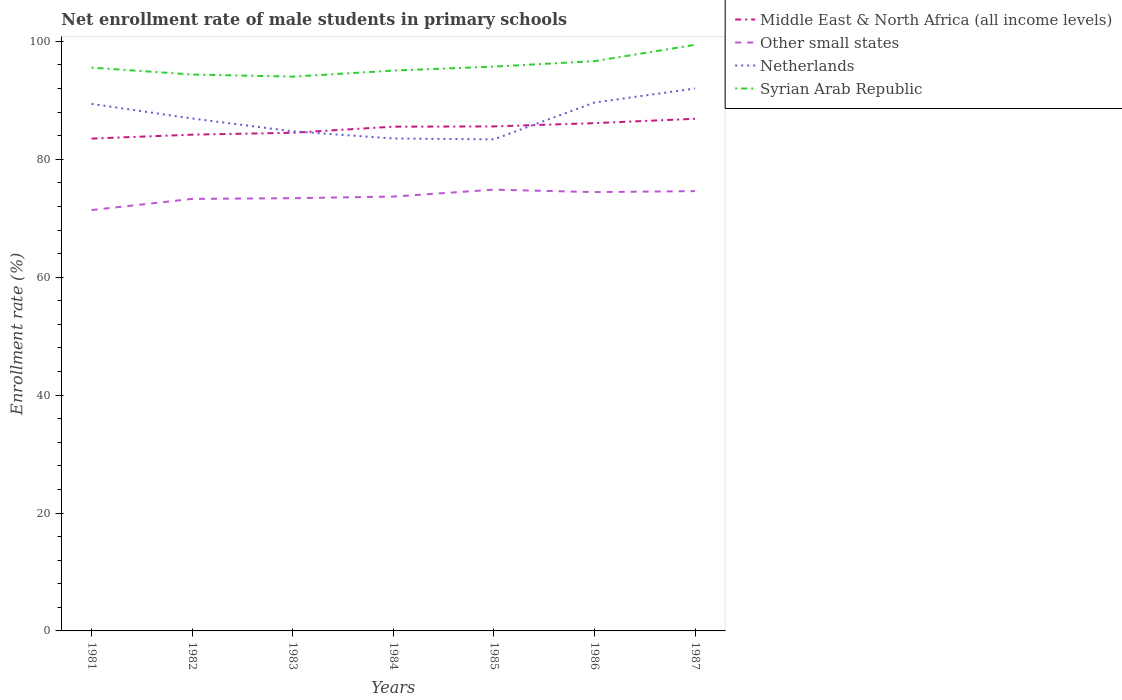Across all years, what is the maximum net enrollment rate of male students in primary schools in Syrian Arab Republic?
Your answer should be very brief. 94.01. In which year was the net enrollment rate of male students in primary schools in Other small states maximum?
Provide a short and direct response. 1981. What is the total net enrollment rate of male students in primary schools in Netherlands in the graph?
Keep it short and to the point. -5.09. What is the difference between the highest and the second highest net enrollment rate of male students in primary schools in Middle East & North Africa (all income levels)?
Provide a short and direct response. 3.36. Are the values on the major ticks of Y-axis written in scientific E-notation?
Provide a short and direct response. No. Does the graph contain grids?
Your answer should be compact. No. Where does the legend appear in the graph?
Keep it short and to the point. Top right. How many legend labels are there?
Ensure brevity in your answer.  4. How are the legend labels stacked?
Make the answer very short. Vertical. What is the title of the graph?
Offer a terse response. Net enrollment rate of male students in primary schools. Does "Ireland" appear as one of the legend labels in the graph?
Offer a very short reply. No. What is the label or title of the X-axis?
Provide a succinct answer. Years. What is the label or title of the Y-axis?
Provide a succinct answer. Enrollment rate (%). What is the Enrollment rate (%) in Middle East & North Africa (all income levels) in 1981?
Give a very brief answer. 83.5. What is the Enrollment rate (%) of Other small states in 1981?
Provide a succinct answer. 71.39. What is the Enrollment rate (%) of Netherlands in 1981?
Offer a very short reply. 89.39. What is the Enrollment rate (%) of Syrian Arab Republic in 1981?
Your answer should be very brief. 95.54. What is the Enrollment rate (%) of Middle East & North Africa (all income levels) in 1982?
Keep it short and to the point. 84.17. What is the Enrollment rate (%) in Other small states in 1982?
Give a very brief answer. 73.27. What is the Enrollment rate (%) of Netherlands in 1982?
Offer a terse response. 86.91. What is the Enrollment rate (%) in Syrian Arab Republic in 1982?
Ensure brevity in your answer.  94.37. What is the Enrollment rate (%) of Middle East & North Africa (all income levels) in 1983?
Offer a terse response. 84.49. What is the Enrollment rate (%) of Other small states in 1983?
Give a very brief answer. 73.4. What is the Enrollment rate (%) of Netherlands in 1983?
Offer a terse response. 84.73. What is the Enrollment rate (%) in Syrian Arab Republic in 1983?
Your response must be concise. 94.01. What is the Enrollment rate (%) of Middle East & North Africa (all income levels) in 1984?
Offer a terse response. 85.53. What is the Enrollment rate (%) of Other small states in 1984?
Ensure brevity in your answer.  73.67. What is the Enrollment rate (%) in Netherlands in 1984?
Give a very brief answer. 83.52. What is the Enrollment rate (%) of Syrian Arab Republic in 1984?
Your answer should be compact. 95.04. What is the Enrollment rate (%) of Middle East & North Africa (all income levels) in 1985?
Provide a short and direct response. 85.57. What is the Enrollment rate (%) in Other small states in 1985?
Make the answer very short. 74.84. What is the Enrollment rate (%) in Netherlands in 1985?
Your answer should be very brief. 83.37. What is the Enrollment rate (%) in Syrian Arab Republic in 1985?
Your answer should be compact. 95.71. What is the Enrollment rate (%) in Middle East & North Africa (all income levels) in 1986?
Make the answer very short. 86.13. What is the Enrollment rate (%) of Other small states in 1986?
Keep it short and to the point. 74.43. What is the Enrollment rate (%) in Netherlands in 1986?
Your answer should be compact. 89.61. What is the Enrollment rate (%) in Syrian Arab Republic in 1986?
Your response must be concise. 96.65. What is the Enrollment rate (%) of Middle East & North Africa (all income levels) in 1987?
Your response must be concise. 86.87. What is the Enrollment rate (%) of Other small states in 1987?
Offer a very short reply. 74.6. What is the Enrollment rate (%) in Netherlands in 1987?
Provide a short and direct response. 92. What is the Enrollment rate (%) of Syrian Arab Republic in 1987?
Give a very brief answer. 99.41. Across all years, what is the maximum Enrollment rate (%) in Middle East & North Africa (all income levels)?
Ensure brevity in your answer.  86.87. Across all years, what is the maximum Enrollment rate (%) of Other small states?
Offer a very short reply. 74.84. Across all years, what is the maximum Enrollment rate (%) in Netherlands?
Provide a succinct answer. 92. Across all years, what is the maximum Enrollment rate (%) of Syrian Arab Republic?
Provide a succinct answer. 99.41. Across all years, what is the minimum Enrollment rate (%) of Middle East & North Africa (all income levels)?
Ensure brevity in your answer.  83.5. Across all years, what is the minimum Enrollment rate (%) in Other small states?
Keep it short and to the point. 71.39. Across all years, what is the minimum Enrollment rate (%) in Netherlands?
Keep it short and to the point. 83.37. Across all years, what is the minimum Enrollment rate (%) in Syrian Arab Republic?
Ensure brevity in your answer.  94.01. What is the total Enrollment rate (%) of Middle East & North Africa (all income levels) in the graph?
Give a very brief answer. 596.25. What is the total Enrollment rate (%) in Other small states in the graph?
Ensure brevity in your answer.  515.6. What is the total Enrollment rate (%) in Netherlands in the graph?
Provide a short and direct response. 609.54. What is the total Enrollment rate (%) of Syrian Arab Republic in the graph?
Your response must be concise. 670.73. What is the difference between the Enrollment rate (%) in Middle East & North Africa (all income levels) in 1981 and that in 1982?
Provide a short and direct response. -0.67. What is the difference between the Enrollment rate (%) in Other small states in 1981 and that in 1982?
Offer a terse response. -1.89. What is the difference between the Enrollment rate (%) in Netherlands in 1981 and that in 1982?
Ensure brevity in your answer.  2.47. What is the difference between the Enrollment rate (%) of Syrian Arab Republic in 1981 and that in 1982?
Make the answer very short. 1.17. What is the difference between the Enrollment rate (%) in Middle East & North Africa (all income levels) in 1981 and that in 1983?
Give a very brief answer. -0.99. What is the difference between the Enrollment rate (%) in Other small states in 1981 and that in 1983?
Provide a succinct answer. -2.01. What is the difference between the Enrollment rate (%) in Netherlands in 1981 and that in 1983?
Make the answer very short. 4.65. What is the difference between the Enrollment rate (%) in Syrian Arab Republic in 1981 and that in 1983?
Give a very brief answer. 1.52. What is the difference between the Enrollment rate (%) in Middle East & North Africa (all income levels) in 1981 and that in 1984?
Your response must be concise. -2.02. What is the difference between the Enrollment rate (%) of Other small states in 1981 and that in 1984?
Keep it short and to the point. -2.29. What is the difference between the Enrollment rate (%) of Netherlands in 1981 and that in 1984?
Your response must be concise. 5.87. What is the difference between the Enrollment rate (%) in Syrian Arab Republic in 1981 and that in 1984?
Make the answer very short. 0.5. What is the difference between the Enrollment rate (%) of Middle East & North Africa (all income levels) in 1981 and that in 1985?
Your response must be concise. -2.06. What is the difference between the Enrollment rate (%) of Other small states in 1981 and that in 1985?
Offer a very short reply. -3.46. What is the difference between the Enrollment rate (%) in Netherlands in 1981 and that in 1985?
Provide a short and direct response. 6.01. What is the difference between the Enrollment rate (%) in Syrian Arab Republic in 1981 and that in 1985?
Make the answer very short. -0.18. What is the difference between the Enrollment rate (%) of Middle East & North Africa (all income levels) in 1981 and that in 1986?
Offer a terse response. -2.62. What is the difference between the Enrollment rate (%) of Other small states in 1981 and that in 1986?
Provide a short and direct response. -3.05. What is the difference between the Enrollment rate (%) in Netherlands in 1981 and that in 1986?
Give a very brief answer. -0.23. What is the difference between the Enrollment rate (%) of Syrian Arab Republic in 1981 and that in 1986?
Ensure brevity in your answer.  -1.11. What is the difference between the Enrollment rate (%) in Middle East & North Africa (all income levels) in 1981 and that in 1987?
Ensure brevity in your answer.  -3.36. What is the difference between the Enrollment rate (%) of Other small states in 1981 and that in 1987?
Give a very brief answer. -3.21. What is the difference between the Enrollment rate (%) of Netherlands in 1981 and that in 1987?
Make the answer very short. -2.62. What is the difference between the Enrollment rate (%) in Syrian Arab Republic in 1981 and that in 1987?
Your answer should be very brief. -3.87. What is the difference between the Enrollment rate (%) of Middle East & North Africa (all income levels) in 1982 and that in 1983?
Your response must be concise. -0.32. What is the difference between the Enrollment rate (%) in Other small states in 1982 and that in 1983?
Offer a terse response. -0.12. What is the difference between the Enrollment rate (%) of Netherlands in 1982 and that in 1983?
Your response must be concise. 2.18. What is the difference between the Enrollment rate (%) of Syrian Arab Republic in 1982 and that in 1983?
Offer a terse response. 0.36. What is the difference between the Enrollment rate (%) of Middle East & North Africa (all income levels) in 1982 and that in 1984?
Make the answer very short. -1.35. What is the difference between the Enrollment rate (%) of Other small states in 1982 and that in 1984?
Offer a very short reply. -0.4. What is the difference between the Enrollment rate (%) in Netherlands in 1982 and that in 1984?
Provide a short and direct response. 3.39. What is the difference between the Enrollment rate (%) in Syrian Arab Republic in 1982 and that in 1984?
Your answer should be compact. -0.67. What is the difference between the Enrollment rate (%) of Middle East & North Africa (all income levels) in 1982 and that in 1985?
Your response must be concise. -1.4. What is the difference between the Enrollment rate (%) in Other small states in 1982 and that in 1985?
Your answer should be very brief. -1.57. What is the difference between the Enrollment rate (%) of Netherlands in 1982 and that in 1985?
Offer a terse response. 3.54. What is the difference between the Enrollment rate (%) of Syrian Arab Republic in 1982 and that in 1985?
Your answer should be very brief. -1.34. What is the difference between the Enrollment rate (%) of Middle East & North Africa (all income levels) in 1982 and that in 1986?
Keep it short and to the point. -1.95. What is the difference between the Enrollment rate (%) in Other small states in 1982 and that in 1986?
Your answer should be compact. -1.16. What is the difference between the Enrollment rate (%) of Netherlands in 1982 and that in 1986?
Your response must be concise. -2.7. What is the difference between the Enrollment rate (%) of Syrian Arab Republic in 1982 and that in 1986?
Your response must be concise. -2.27. What is the difference between the Enrollment rate (%) of Middle East & North Africa (all income levels) in 1982 and that in 1987?
Your answer should be very brief. -2.69. What is the difference between the Enrollment rate (%) in Other small states in 1982 and that in 1987?
Make the answer very short. -1.32. What is the difference between the Enrollment rate (%) of Netherlands in 1982 and that in 1987?
Give a very brief answer. -5.09. What is the difference between the Enrollment rate (%) in Syrian Arab Republic in 1982 and that in 1987?
Provide a short and direct response. -5.03. What is the difference between the Enrollment rate (%) of Middle East & North Africa (all income levels) in 1983 and that in 1984?
Give a very brief answer. -1.03. What is the difference between the Enrollment rate (%) in Other small states in 1983 and that in 1984?
Offer a terse response. -0.28. What is the difference between the Enrollment rate (%) of Netherlands in 1983 and that in 1984?
Make the answer very short. 1.22. What is the difference between the Enrollment rate (%) of Syrian Arab Republic in 1983 and that in 1984?
Give a very brief answer. -1.03. What is the difference between the Enrollment rate (%) in Middle East & North Africa (all income levels) in 1983 and that in 1985?
Offer a terse response. -1.08. What is the difference between the Enrollment rate (%) in Other small states in 1983 and that in 1985?
Provide a succinct answer. -1.45. What is the difference between the Enrollment rate (%) of Netherlands in 1983 and that in 1985?
Ensure brevity in your answer.  1.36. What is the difference between the Enrollment rate (%) in Syrian Arab Republic in 1983 and that in 1985?
Your answer should be compact. -1.7. What is the difference between the Enrollment rate (%) of Middle East & North Africa (all income levels) in 1983 and that in 1986?
Offer a very short reply. -1.63. What is the difference between the Enrollment rate (%) of Other small states in 1983 and that in 1986?
Give a very brief answer. -1.03. What is the difference between the Enrollment rate (%) in Netherlands in 1983 and that in 1986?
Provide a succinct answer. -4.88. What is the difference between the Enrollment rate (%) of Syrian Arab Republic in 1983 and that in 1986?
Your answer should be compact. -2.63. What is the difference between the Enrollment rate (%) in Middle East & North Africa (all income levels) in 1983 and that in 1987?
Keep it short and to the point. -2.37. What is the difference between the Enrollment rate (%) of Other small states in 1983 and that in 1987?
Your response must be concise. -1.2. What is the difference between the Enrollment rate (%) in Netherlands in 1983 and that in 1987?
Your answer should be compact. -7.27. What is the difference between the Enrollment rate (%) of Syrian Arab Republic in 1983 and that in 1987?
Ensure brevity in your answer.  -5.39. What is the difference between the Enrollment rate (%) in Middle East & North Africa (all income levels) in 1984 and that in 1985?
Provide a succinct answer. -0.04. What is the difference between the Enrollment rate (%) of Other small states in 1984 and that in 1985?
Keep it short and to the point. -1.17. What is the difference between the Enrollment rate (%) of Netherlands in 1984 and that in 1985?
Provide a short and direct response. 0.15. What is the difference between the Enrollment rate (%) of Syrian Arab Republic in 1984 and that in 1985?
Your answer should be very brief. -0.68. What is the difference between the Enrollment rate (%) in Middle East & North Africa (all income levels) in 1984 and that in 1986?
Provide a succinct answer. -0.6. What is the difference between the Enrollment rate (%) in Other small states in 1984 and that in 1986?
Ensure brevity in your answer.  -0.76. What is the difference between the Enrollment rate (%) in Netherlands in 1984 and that in 1986?
Offer a terse response. -6.09. What is the difference between the Enrollment rate (%) in Syrian Arab Republic in 1984 and that in 1986?
Your answer should be very brief. -1.61. What is the difference between the Enrollment rate (%) in Middle East & North Africa (all income levels) in 1984 and that in 1987?
Make the answer very short. -1.34. What is the difference between the Enrollment rate (%) of Other small states in 1984 and that in 1987?
Provide a short and direct response. -0.93. What is the difference between the Enrollment rate (%) in Netherlands in 1984 and that in 1987?
Your response must be concise. -8.49. What is the difference between the Enrollment rate (%) in Syrian Arab Republic in 1984 and that in 1987?
Your answer should be very brief. -4.37. What is the difference between the Enrollment rate (%) in Middle East & North Africa (all income levels) in 1985 and that in 1986?
Provide a succinct answer. -0.56. What is the difference between the Enrollment rate (%) of Other small states in 1985 and that in 1986?
Provide a short and direct response. 0.41. What is the difference between the Enrollment rate (%) of Netherlands in 1985 and that in 1986?
Ensure brevity in your answer.  -6.24. What is the difference between the Enrollment rate (%) of Syrian Arab Republic in 1985 and that in 1986?
Your response must be concise. -0.93. What is the difference between the Enrollment rate (%) of Middle East & North Africa (all income levels) in 1985 and that in 1987?
Offer a very short reply. -1.3. What is the difference between the Enrollment rate (%) in Other small states in 1985 and that in 1987?
Your answer should be compact. 0.25. What is the difference between the Enrollment rate (%) of Netherlands in 1985 and that in 1987?
Offer a very short reply. -8.63. What is the difference between the Enrollment rate (%) in Syrian Arab Republic in 1985 and that in 1987?
Offer a very short reply. -3.69. What is the difference between the Enrollment rate (%) in Middle East & North Africa (all income levels) in 1986 and that in 1987?
Your response must be concise. -0.74. What is the difference between the Enrollment rate (%) in Other small states in 1986 and that in 1987?
Give a very brief answer. -0.17. What is the difference between the Enrollment rate (%) in Netherlands in 1986 and that in 1987?
Ensure brevity in your answer.  -2.39. What is the difference between the Enrollment rate (%) of Syrian Arab Republic in 1986 and that in 1987?
Your response must be concise. -2.76. What is the difference between the Enrollment rate (%) of Middle East & North Africa (all income levels) in 1981 and the Enrollment rate (%) of Other small states in 1982?
Offer a terse response. 10.23. What is the difference between the Enrollment rate (%) of Middle East & North Africa (all income levels) in 1981 and the Enrollment rate (%) of Netherlands in 1982?
Your answer should be very brief. -3.41. What is the difference between the Enrollment rate (%) of Middle East & North Africa (all income levels) in 1981 and the Enrollment rate (%) of Syrian Arab Republic in 1982?
Keep it short and to the point. -10.87. What is the difference between the Enrollment rate (%) of Other small states in 1981 and the Enrollment rate (%) of Netherlands in 1982?
Offer a terse response. -15.53. What is the difference between the Enrollment rate (%) in Other small states in 1981 and the Enrollment rate (%) in Syrian Arab Republic in 1982?
Offer a terse response. -22.99. What is the difference between the Enrollment rate (%) of Netherlands in 1981 and the Enrollment rate (%) of Syrian Arab Republic in 1982?
Your answer should be compact. -4.98. What is the difference between the Enrollment rate (%) of Middle East & North Africa (all income levels) in 1981 and the Enrollment rate (%) of Other small states in 1983?
Your response must be concise. 10.11. What is the difference between the Enrollment rate (%) in Middle East & North Africa (all income levels) in 1981 and the Enrollment rate (%) in Netherlands in 1983?
Offer a very short reply. -1.23. What is the difference between the Enrollment rate (%) of Middle East & North Africa (all income levels) in 1981 and the Enrollment rate (%) of Syrian Arab Republic in 1983?
Make the answer very short. -10.51. What is the difference between the Enrollment rate (%) in Other small states in 1981 and the Enrollment rate (%) in Netherlands in 1983?
Provide a short and direct response. -13.35. What is the difference between the Enrollment rate (%) in Other small states in 1981 and the Enrollment rate (%) in Syrian Arab Republic in 1983?
Offer a terse response. -22.63. What is the difference between the Enrollment rate (%) of Netherlands in 1981 and the Enrollment rate (%) of Syrian Arab Republic in 1983?
Make the answer very short. -4.63. What is the difference between the Enrollment rate (%) of Middle East & North Africa (all income levels) in 1981 and the Enrollment rate (%) of Other small states in 1984?
Make the answer very short. 9.83. What is the difference between the Enrollment rate (%) of Middle East & North Africa (all income levels) in 1981 and the Enrollment rate (%) of Netherlands in 1984?
Offer a very short reply. -0.02. What is the difference between the Enrollment rate (%) in Middle East & North Africa (all income levels) in 1981 and the Enrollment rate (%) in Syrian Arab Republic in 1984?
Make the answer very short. -11.54. What is the difference between the Enrollment rate (%) of Other small states in 1981 and the Enrollment rate (%) of Netherlands in 1984?
Provide a succinct answer. -12.13. What is the difference between the Enrollment rate (%) in Other small states in 1981 and the Enrollment rate (%) in Syrian Arab Republic in 1984?
Offer a terse response. -23.65. What is the difference between the Enrollment rate (%) of Netherlands in 1981 and the Enrollment rate (%) of Syrian Arab Republic in 1984?
Offer a very short reply. -5.65. What is the difference between the Enrollment rate (%) of Middle East & North Africa (all income levels) in 1981 and the Enrollment rate (%) of Other small states in 1985?
Offer a very short reply. 8.66. What is the difference between the Enrollment rate (%) of Middle East & North Africa (all income levels) in 1981 and the Enrollment rate (%) of Netherlands in 1985?
Keep it short and to the point. 0.13. What is the difference between the Enrollment rate (%) of Middle East & North Africa (all income levels) in 1981 and the Enrollment rate (%) of Syrian Arab Republic in 1985?
Your answer should be very brief. -12.21. What is the difference between the Enrollment rate (%) in Other small states in 1981 and the Enrollment rate (%) in Netherlands in 1985?
Make the answer very short. -11.99. What is the difference between the Enrollment rate (%) in Other small states in 1981 and the Enrollment rate (%) in Syrian Arab Republic in 1985?
Make the answer very short. -24.33. What is the difference between the Enrollment rate (%) in Netherlands in 1981 and the Enrollment rate (%) in Syrian Arab Republic in 1985?
Your response must be concise. -6.33. What is the difference between the Enrollment rate (%) in Middle East & North Africa (all income levels) in 1981 and the Enrollment rate (%) in Other small states in 1986?
Offer a very short reply. 9.07. What is the difference between the Enrollment rate (%) in Middle East & North Africa (all income levels) in 1981 and the Enrollment rate (%) in Netherlands in 1986?
Give a very brief answer. -6.11. What is the difference between the Enrollment rate (%) of Middle East & North Africa (all income levels) in 1981 and the Enrollment rate (%) of Syrian Arab Republic in 1986?
Ensure brevity in your answer.  -13.14. What is the difference between the Enrollment rate (%) in Other small states in 1981 and the Enrollment rate (%) in Netherlands in 1986?
Your answer should be very brief. -18.23. What is the difference between the Enrollment rate (%) in Other small states in 1981 and the Enrollment rate (%) in Syrian Arab Republic in 1986?
Give a very brief answer. -25.26. What is the difference between the Enrollment rate (%) of Netherlands in 1981 and the Enrollment rate (%) of Syrian Arab Republic in 1986?
Provide a short and direct response. -7.26. What is the difference between the Enrollment rate (%) of Middle East & North Africa (all income levels) in 1981 and the Enrollment rate (%) of Other small states in 1987?
Keep it short and to the point. 8.91. What is the difference between the Enrollment rate (%) of Middle East & North Africa (all income levels) in 1981 and the Enrollment rate (%) of Netherlands in 1987?
Your response must be concise. -8.5. What is the difference between the Enrollment rate (%) in Middle East & North Africa (all income levels) in 1981 and the Enrollment rate (%) in Syrian Arab Republic in 1987?
Give a very brief answer. -15.9. What is the difference between the Enrollment rate (%) in Other small states in 1981 and the Enrollment rate (%) in Netherlands in 1987?
Your response must be concise. -20.62. What is the difference between the Enrollment rate (%) in Other small states in 1981 and the Enrollment rate (%) in Syrian Arab Republic in 1987?
Give a very brief answer. -28.02. What is the difference between the Enrollment rate (%) of Netherlands in 1981 and the Enrollment rate (%) of Syrian Arab Republic in 1987?
Make the answer very short. -10.02. What is the difference between the Enrollment rate (%) in Middle East & North Africa (all income levels) in 1982 and the Enrollment rate (%) in Other small states in 1983?
Provide a succinct answer. 10.78. What is the difference between the Enrollment rate (%) in Middle East & North Africa (all income levels) in 1982 and the Enrollment rate (%) in Netherlands in 1983?
Ensure brevity in your answer.  -0.56. What is the difference between the Enrollment rate (%) in Middle East & North Africa (all income levels) in 1982 and the Enrollment rate (%) in Syrian Arab Republic in 1983?
Offer a terse response. -9.84. What is the difference between the Enrollment rate (%) in Other small states in 1982 and the Enrollment rate (%) in Netherlands in 1983?
Provide a short and direct response. -11.46. What is the difference between the Enrollment rate (%) of Other small states in 1982 and the Enrollment rate (%) of Syrian Arab Republic in 1983?
Offer a terse response. -20.74. What is the difference between the Enrollment rate (%) of Netherlands in 1982 and the Enrollment rate (%) of Syrian Arab Republic in 1983?
Provide a short and direct response. -7.1. What is the difference between the Enrollment rate (%) of Middle East & North Africa (all income levels) in 1982 and the Enrollment rate (%) of Other small states in 1984?
Offer a very short reply. 10.5. What is the difference between the Enrollment rate (%) in Middle East & North Africa (all income levels) in 1982 and the Enrollment rate (%) in Netherlands in 1984?
Offer a terse response. 0.65. What is the difference between the Enrollment rate (%) of Middle East & North Africa (all income levels) in 1982 and the Enrollment rate (%) of Syrian Arab Republic in 1984?
Ensure brevity in your answer.  -10.87. What is the difference between the Enrollment rate (%) of Other small states in 1982 and the Enrollment rate (%) of Netherlands in 1984?
Your answer should be compact. -10.24. What is the difference between the Enrollment rate (%) of Other small states in 1982 and the Enrollment rate (%) of Syrian Arab Republic in 1984?
Your answer should be very brief. -21.76. What is the difference between the Enrollment rate (%) of Netherlands in 1982 and the Enrollment rate (%) of Syrian Arab Republic in 1984?
Your answer should be compact. -8.13. What is the difference between the Enrollment rate (%) of Middle East & North Africa (all income levels) in 1982 and the Enrollment rate (%) of Other small states in 1985?
Offer a terse response. 9.33. What is the difference between the Enrollment rate (%) of Middle East & North Africa (all income levels) in 1982 and the Enrollment rate (%) of Netherlands in 1985?
Give a very brief answer. 0.8. What is the difference between the Enrollment rate (%) in Middle East & North Africa (all income levels) in 1982 and the Enrollment rate (%) in Syrian Arab Republic in 1985?
Provide a short and direct response. -11.54. What is the difference between the Enrollment rate (%) in Other small states in 1982 and the Enrollment rate (%) in Netherlands in 1985?
Give a very brief answer. -10.1. What is the difference between the Enrollment rate (%) in Other small states in 1982 and the Enrollment rate (%) in Syrian Arab Republic in 1985?
Provide a succinct answer. -22.44. What is the difference between the Enrollment rate (%) in Netherlands in 1982 and the Enrollment rate (%) in Syrian Arab Republic in 1985?
Make the answer very short. -8.8. What is the difference between the Enrollment rate (%) in Middle East & North Africa (all income levels) in 1982 and the Enrollment rate (%) in Other small states in 1986?
Your response must be concise. 9.74. What is the difference between the Enrollment rate (%) of Middle East & North Africa (all income levels) in 1982 and the Enrollment rate (%) of Netherlands in 1986?
Your answer should be very brief. -5.44. What is the difference between the Enrollment rate (%) of Middle East & North Africa (all income levels) in 1982 and the Enrollment rate (%) of Syrian Arab Republic in 1986?
Give a very brief answer. -12.47. What is the difference between the Enrollment rate (%) of Other small states in 1982 and the Enrollment rate (%) of Netherlands in 1986?
Make the answer very short. -16.34. What is the difference between the Enrollment rate (%) in Other small states in 1982 and the Enrollment rate (%) in Syrian Arab Republic in 1986?
Offer a terse response. -23.37. What is the difference between the Enrollment rate (%) of Netherlands in 1982 and the Enrollment rate (%) of Syrian Arab Republic in 1986?
Offer a terse response. -9.73. What is the difference between the Enrollment rate (%) in Middle East & North Africa (all income levels) in 1982 and the Enrollment rate (%) in Other small states in 1987?
Make the answer very short. 9.58. What is the difference between the Enrollment rate (%) in Middle East & North Africa (all income levels) in 1982 and the Enrollment rate (%) in Netherlands in 1987?
Offer a terse response. -7.83. What is the difference between the Enrollment rate (%) of Middle East & North Africa (all income levels) in 1982 and the Enrollment rate (%) of Syrian Arab Republic in 1987?
Ensure brevity in your answer.  -15.23. What is the difference between the Enrollment rate (%) of Other small states in 1982 and the Enrollment rate (%) of Netherlands in 1987?
Make the answer very short. -18.73. What is the difference between the Enrollment rate (%) of Other small states in 1982 and the Enrollment rate (%) of Syrian Arab Republic in 1987?
Provide a succinct answer. -26.13. What is the difference between the Enrollment rate (%) in Netherlands in 1982 and the Enrollment rate (%) in Syrian Arab Republic in 1987?
Your response must be concise. -12.49. What is the difference between the Enrollment rate (%) of Middle East & North Africa (all income levels) in 1983 and the Enrollment rate (%) of Other small states in 1984?
Provide a succinct answer. 10.82. What is the difference between the Enrollment rate (%) of Middle East & North Africa (all income levels) in 1983 and the Enrollment rate (%) of Netherlands in 1984?
Ensure brevity in your answer.  0.97. What is the difference between the Enrollment rate (%) in Middle East & North Africa (all income levels) in 1983 and the Enrollment rate (%) in Syrian Arab Republic in 1984?
Ensure brevity in your answer.  -10.55. What is the difference between the Enrollment rate (%) in Other small states in 1983 and the Enrollment rate (%) in Netherlands in 1984?
Your answer should be compact. -10.12. What is the difference between the Enrollment rate (%) of Other small states in 1983 and the Enrollment rate (%) of Syrian Arab Republic in 1984?
Provide a succinct answer. -21.64. What is the difference between the Enrollment rate (%) of Netherlands in 1983 and the Enrollment rate (%) of Syrian Arab Republic in 1984?
Offer a very short reply. -10.3. What is the difference between the Enrollment rate (%) in Middle East & North Africa (all income levels) in 1983 and the Enrollment rate (%) in Other small states in 1985?
Give a very brief answer. 9.65. What is the difference between the Enrollment rate (%) of Middle East & North Africa (all income levels) in 1983 and the Enrollment rate (%) of Netherlands in 1985?
Ensure brevity in your answer.  1.12. What is the difference between the Enrollment rate (%) of Middle East & North Africa (all income levels) in 1983 and the Enrollment rate (%) of Syrian Arab Republic in 1985?
Give a very brief answer. -11.22. What is the difference between the Enrollment rate (%) in Other small states in 1983 and the Enrollment rate (%) in Netherlands in 1985?
Provide a short and direct response. -9.98. What is the difference between the Enrollment rate (%) of Other small states in 1983 and the Enrollment rate (%) of Syrian Arab Republic in 1985?
Provide a short and direct response. -22.32. What is the difference between the Enrollment rate (%) in Netherlands in 1983 and the Enrollment rate (%) in Syrian Arab Republic in 1985?
Provide a succinct answer. -10.98. What is the difference between the Enrollment rate (%) in Middle East & North Africa (all income levels) in 1983 and the Enrollment rate (%) in Other small states in 1986?
Your response must be concise. 10.06. What is the difference between the Enrollment rate (%) of Middle East & North Africa (all income levels) in 1983 and the Enrollment rate (%) of Netherlands in 1986?
Make the answer very short. -5.12. What is the difference between the Enrollment rate (%) in Middle East & North Africa (all income levels) in 1983 and the Enrollment rate (%) in Syrian Arab Republic in 1986?
Your answer should be very brief. -12.15. What is the difference between the Enrollment rate (%) in Other small states in 1983 and the Enrollment rate (%) in Netherlands in 1986?
Provide a short and direct response. -16.22. What is the difference between the Enrollment rate (%) in Other small states in 1983 and the Enrollment rate (%) in Syrian Arab Republic in 1986?
Make the answer very short. -23.25. What is the difference between the Enrollment rate (%) of Netherlands in 1983 and the Enrollment rate (%) of Syrian Arab Republic in 1986?
Provide a short and direct response. -11.91. What is the difference between the Enrollment rate (%) of Middle East & North Africa (all income levels) in 1983 and the Enrollment rate (%) of Other small states in 1987?
Make the answer very short. 9.9. What is the difference between the Enrollment rate (%) in Middle East & North Africa (all income levels) in 1983 and the Enrollment rate (%) in Netherlands in 1987?
Your answer should be compact. -7.51. What is the difference between the Enrollment rate (%) of Middle East & North Africa (all income levels) in 1983 and the Enrollment rate (%) of Syrian Arab Republic in 1987?
Make the answer very short. -14.91. What is the difference between the Enrollment rate (%) in Other small states in 1983 and the Enrollment rate (%) in Netherlands in 1987?
Make the answer very short. -18.61. What is the difference between the Enrollment rate (%) of Other small states in 1983 and the Enrollment rate (%) of Syrian Arab Republic in 1987?
Your answer should be compact. -26.01. What is the difference between the Enrollment rate (%) of Netherlands in 1983 and the Enrollment rate (%) of Syrian Arab Republic in 1987?
Your answer should be very brief. -14.67. What is the difference between the Enrollment rate (%) in Middle East & North Africa (all income levels) in 1984 and the Enrollment rate (%) in Other small states in 1985?
Make the answer very short. 10.68. What is the difference between the Enrollment rate (%) of Middle East & North Africa (all income levels) in 1984 and the Enrollment rate (%) of Netherlands in 1985?
Give a very brief answer. 2.15. What is the difference between the Enrollment rate (%) of Middle East & North Africa (all income levels) in 1984 and the Enrollment rate (%) of Syrian Arab Republic in 1985?
Ensure brevity in your answer.  -10.19. What is the difference between the Enrollment rate (%) in Other small states in 1984 and the Enrollment rate (%) in Netherlands in 1985?
Your answer should be very brief. -9.7. What is the difference between the Enrollment rate (%) of Other small states in 1984 and the Enrollment rate (%) of Syrian Arab Republic in 1985?
Provide a short and direct response. -22.04. What is the difference between the Enrollment rate (%) of Netherlands in 1984 and the Enrollment rate (%) of Syrian Arab Republic in 1985?
Offer a terse response. -12.2. What is the difference between the Enrollment rate (%) in Middle East & North Africa (all income levels) in 1984 and the Enrollment rate (%) in Other small states in 1986?
Make the answer very short. 11.1. What is the difference between the Enrollment rate (%) in Middle East & North Africa (all income levels) in 1984 and the Enrollment rate (%) in Netherlands in 1986?
Keep it short and to the point. -4.09. What is the difference between the Enrollment rate (%) of Middle East & North Africa (all income levels) in 1984 and the Enrollment rate (%) of Syrian Arab Republic in 1986?
Your response must be concise. -11.12. What is the difference between the Enrollment rate (%) of Other small states in 1984 and the Enrollment rate (%) of Netherlands in 1986?
Offer a very short reply. -15.94. What is the difference between the Enrollment rate (%) of Other small states in 1984 and the Enrollment rate (%) of Syrian Arab Republic in 1986?
Give a very brief answer. -22.97. What is the difference between the Enrollment rate (%) of Netherlands in 1984 and the Enrollment rate (%) of Syrian Arab Republic in 1986?
Offer a terse response. -13.13. What is the difference between the Enrollment rate (%) of Middle East & North Africa (all income levels) in 1984 and the Enrollment rate (%) of Other small states in 1987?
Ensure brevity in your answer.  10.93. What is the difference between the Enrollment rate (%) of Middle East & North Africa (all income levels) in 1984 and the Enrollment rate (%) of Netherlands in 1987?
Your response must be concise. -6.48. What is the difference between the Enrollment rate (%) in Middle East & North Africa (all income levels) in 1984 and the Enrollment rate (%) in Syrian Arab Republic in 1987?
Make the answer very short. -13.88. What is the difference between the Enrollment rate (%) of Other small states in 1984 and the Enrollment rate (%) of Netherlands in 1987?
Provide a short and direct response. -18.33. What is the difference between the Enrollment rate (%) in Other small states in 1984 and the Enrollment rate (%) in Syrian Arab Republic in 1987?
Give a very brief answer. -25.73. What is the difference between the Enrollment rate (%) in Netherlands in 1984 and the Enrollment rate (%) in Syrian Arab Republic in 1987?
Give a very brief answer. -15.89. What is the difference between the Enrollment rate (%) of Middle East & North Africa (all income levels) in 1985 and the Enrollment rate (%) of Other small states in 1986?
Your answer should be very brief. 11.14. What is the difference between the Enrollment rate (%) in Middle East & North Africa (all income levels) in 1985 and the Enrollment rate (%) in Netherlands in 1986?
Make the answer very short. -4.04. What is the difference between the Enrollment rate (%) in Middle East & North Africa (all income levels) in 1985 and the Enrollment rate (%) in Syrian Arab Republic in 1986?
Offer a terse response. -11.08. What is the difference between the Enrollment rate (%) in Other small states in 1985 and the Enrollment rate (%) in Netherlands in 1986?
Keep it short and to the point. -14.77. What is the difference between the Enrollment rate (%) of Other small states in 1985 and the Enrollment rate (%) of Syrian Arab Republic in 1986?
Make the answer very short. -21.8. What is the difference between the Enrollment rate (%) of Netherlands in 1985 and the Enrollment rate (%) of Syrian Arab Republic in 1986?
Make the answer very short. -13.27. What is the difference between the Enrollment rate (%) in Middle East & North Africa (all income levels) in 1985 and the Enrollment rate (%) in Other small states in 1987?
Provide a succinct answer. 10.97. What is the difference between the Enrollment rate (%) in Middle East & North Africa (all income levels) in 1985 and the Enrollment rate (%) in Netherlands in 1987?
Your answer should be very brief. -6.44. What is the difference between the Enrollment rate (%) in Middle East & North Africa (all income levels) in 1985 and the Enrollment rate (%) in Syrian Arab Republic in 1987?
Make the answer very short. -13.84. What is the difference between the Enrollment rate (%) of Other small states in 1985 and the Enrollment rate (%) of Netherlands in 1987?
Your answer should be compact. -17.16. What is the difference between the Enrollment rate (%) of Other small states in 1985 and the Enrollment rate (%) of Syrian Arab Republic in 1987?
Your answer should be very brief. -24.56. What is the difference between the Enrollment rate (%) in Netherlands in 1985 and the Enrollment rate (%) in Syrian Arab Republic in 1987?
Provide a succinct answer. -16.03. What is the difference between the Enrollment rate (%) of Middle East & North Africa (all income levels) in 1986 and the Enrollment rate (%) of Other small states in 1987?
Provide a short and direct response. 11.53. What is the difference between the Enrollment rate (%) of Middle East & North Africa (all income levels) in 1986 and the Enrollment rate (%) of Netherlands in 1987?
Provide a short and direct response. -5.88. What is the difference between the Enrollment rate (%) of Middle East & North Africa (all income levels) in 1986 and the Enrollment rate (%) of Syrian Arab Republic in 1987?
Your response must be concise. -13.28. What is the difference between the Enrollment rate (%) of Other small states in 1986 and the Enrollment rate (%) of Netherlands in 1987?
Provide a short and direct response. -17.57. What is the difference between the Enrollment rate (%) of Other small states in 1986 and the Enrollment rate (%) of Syrian Arab Republic in 1987?
Your response must be concise. -24.98. What is the difference between the Enrollment rate (%) in Netherlands in 1986 and the Enrollment rate (%) in Syrian Arab Republic in 1987?
Provide a succinct answer. -9.79. What is the average Enrollment rate (%) of Middle East & North Africa (all income levels) per year?
Your answer should be compact. 85.18. What is the average Enrollment rate (%) of Other small states per year?
Ensure brevity in your answer.  73.66. What is the average Enrollment rate (%) in Netherlands per year?
Provide a short and direct response. 87.08. What is the average Enrollment rate (%) of Syrian Arab Republic per year?
Your answer should be compact. 95.82. In the year 1981, what is the difference between the Enrollment rate (%) of Middle East & North Africa (all income levels) and Enrollment rate (%) of Other small states?
Give a very brief answer. 12.12. In the year 1981, what is the difference between the Enrollment rate (%) of Middle East & North Africa (all income levels) and Enrollment rate (%) of Netherlands?
Give a very brief answer. -5.88. In the year 1981, what is the difference between the Enrollment rate (%) of Middle East & North Africa (all income levels) and Enrollment rate (%) of Syrian Arab Republic?
Provide a short and direct response. -12.03. In the year 1981, what is the difference between the Enrollment rate (%) of Other small states and Enrollment rate (%) of Netherlands?
Your response must be concise. -18. In the year 1981, what is the difference between the Enrollment rate (%) in Other small states and Enrollment rate (%) in Syrian Arab Republic?
Make the answer very short. -24.15. In the year 1981, what is the difference between the Enrollment rate (%) in Netherlands and Enrollment rate (%) in Syrian Arab Republic?
Give a very brief answer. -6.15. In the year 1982, what is the difference between the Enrollment rate (%) of Middle East & North Africa (all income levels) and Enrollment rate (%) of Other small states?
Provide a succinct answer. 10.9. In the year 1982, what is the difference between the Enrollment rate (%) of Middle East & North Africa (all income levels) and Enrollment rate (%) of Netherlands?
Provide a short and direct response. -2.74. In the year 1982, what is the difference between the Enrollment rate (%) in Middle East & North Africa (all income levels) and Enrollment rate (%) in Syrian Arab Republic?
Offer a very short reply. -10.2. In the year 1982, what is the difference between the Enrollment rate (%) of Other small states and Enrollment rate (%) of Netherlands?
Your answer should be compact. -13.64. In the year 1982, what is the difference between the Enrollment rate (%) of Other small states and Enrollment rate (%) of Syrian Arab Republic?
Make the answer very short. -21.1. In the year 1982, what is the difference between the Enrollment rate (%) of Netherlands and Enrollment rate (%) of Syrian Arab Republic?
Make the answer very short. -7.46. In the year 1983, what is the difference between the Enrollment rate (%) of Middle East & North Africa (all income levels) and Enrollment rate (%) of Other small states?
Your answer should be very brief. 11.1. In the year 1983, what is the difference between the Enrollment rate (%) of Middle East & North Africa (all income levels) and Enrollment rate (%) of Netherlands?
Your answer should be very brief. -0.24. In the year 1983, what is the difference between the Enrollment rate (%) of Middle East & North Africa (all income levels) and Enrollment rate (%) of Syrian Arab Republic?
Your answer should be compact. -9.52. In the year 1983, what is the difference between the Enrollment rate (%) in Other small states and Enrollment rate (%) in Netherlands?
Keep it short and to the point. -11.34. In the year 1983, what is the difference between the Enrollment rate (%) of Other small states and Enrollment rate (%) of Syrian Arab Republic?
Make the answer very short. -20.62. In the year 1983, what is the difference between the Enrollment rate (%) of Netherlands and Enrollment rate (%) of Syrian Arab Republic?
Your answer should be very brief. -9.28. In the year 1984, what is the difference between the Enrollment rate (%) in Middle East & North Africa (all income levels) and Enrollment rate (%) in Other small states?
Ensure brevity in your answer.  11.85. In the year 1984, what is the difference between the Enrollment rate (%) in Middle East & North Africa (all income levels) and Enrollment rate (%) in Netherlands?
Your response must be concise. 2.01. In the year 1984, what is the difference between the Enrollment rate (%) of Middle East & North Africa (all income levels) and Enrollment rate (%) of Syrian Arab Republic?
Make the answer very short. -9.51. In the year 1984, what is the difference between the Enrollment rate (%) in Other small states and Enrollment rate (%) in Netherlands?
Make the answer very short. -9.85. In the year 1984, what is the difference between the Enrollment rate (%) of Other small states and Enrollment rate (%) of Syrian Arab Republic?
Ensure brevity in your answer.  -21.37. In the year 1984, what is the difference between the Enrollment rate (%) in Netherlands and Enrollment rate (%) in Syrian Arab Republic?
Offer a terse response. -11.52. In the year 1985, what is the difference between the Enrollment rate (%) of Middle East & North Africa (all income levels) and Enrollment rate (%) of Other small states?
Keep it short and to the point. 10.72. In the year 1985, what is the difference between the Enrollment rate (%) of Middle East & North Africa (all income levels) and Enrollment rate (%) of Netherlands?
Give a very brief answer. 2.2. In the year 1985, what is the difference between the Enrollment rate (%) of Middle East & North Africa (all income levels) and Enrollment rate (%) of Syrian Arab Republic?
Provide a short and direct response. -10.15. In the year 1985, what is the difference between the Enrollment rate (%) of Other small states and Enrollment rate (%) of Netherlands?
Offer a terse response. -8.53. In the year 1985, what is the difference between the Enrollment rate (%) in Other small states and Enrollment rate (%) in Syrian Arab Republic?
Provide a succinct answer. -20.87. In the year 1985, what is the difference between the Enrollment rate (%) of Netherlands and Enrollment rate (%) of Syrian Arab Republic?
Your answer should be very brief. -12.34. In the year 1986, what is the difference between the Enrollment rate (%) in Middle East & North Africa (all income levels) and Enrollment rate (%) in Other small states?
Your answer should be compact. 11.7. In the year 1986, what is the difference between the Enrollment rate (%) of Middle East & North Africa (all income levels) and Enrollment rate (%) of Netherlands?
Offer a very short reply. -3.49. In the year 1986, what is the difference between the Enrollment rate (%) of Middle East & North Africa (all income levels) and Enrollment rate (%) of Syrian Arab Republic?
Your answer should be compact. -10.52. In the year 1986, what is the difference between the Enrollment rate (%) in Other small states and Enrollment rate (%) in Netherlands?
Offer a very short reply. -15.18. In the year 1986, what is the difference between the Enrollment rate (%) of Other small states and Enrollment rate (%) of Syrian Arab Republic?
Offer a terse response. -22.21. In the year 1986, what is the difference between the Enrollment rate (%) in Netherlands and Enrollment rate (%) in Syrian Arab Republic?
Your response must be concise. -7.03. In the year 1987, what is the difference between the Enrollment rate (%) in Middle East & North Africa (all income levels) and Enrollment rate (%) in Other small states?
Offer a terse response. 12.27. In the year 1987, what is the difference between the Enrollment rate (%) in Middle East & North Africa (all income levels) and Enrollment rate (%) in Netherlands?
Offer a very short reply. -5.14. In the year 1987, what is the difference between the Enrollment rate (%) of Middle East & North Africa (all income levels) and Enrollment rate (%) of Syrian Arab Republic?
Your answer should be compact. -12.54. In the year 1987, what is the difference between the Enrollment rate (%) in Other small states and Enrollment rate (%) in Netherlands?
Your answer should be very brief. -17.41. In the year 1987, what is the difference between the Enrollment rate (%) in Other small states and Enrollment rate (%) in Syrian Arab Republic?
Provide a succinct answer. -24.81. In the year 1987, what is the difference between the Enrollment rate (%) in Netherlands and Enrollment rate (%) in Syrian Arab Republic?
Your answer should be compact. -7.4. What is the ratio of the Enrollment rate (%) of Middle East & North Africa (all income levels) in 1981 to that in 1982?
Make the answer very short. 0.99. What is the ratio of the Enrollment rate (%) in Other small states in 1981 to that in 1982?
Offer a very short reply. 0.97. What is the ratio of the Enrollment rate (%) of Netherlands in 1981 to that in 1982?
Make the answer very short. 1.03. What is the ratio of the Enrollment rate (%) in Syrian Arab Republic in 1981 to that in 1982?
Offer a terse response. 1.01. What is the ratio of the Enrollment rate (%) in Middle East & North Africa (all income levels) in 1981 to that in 1983?
Provide a succinct answer. 0.99. What is the ratio of the Enrollment rate (%) in Other small states in 1981 to that in 1983?
Offer a very short reply. 0.97. What is the ratio of the Enrollment rate (%) in Netherlands in 1981 to that in 1983?
Provide a short and direct response. 1.05. What is the ratio of the Enrollment rate (%) of Syrian Arab Republic in 1981 to that in 1983?
Ensure brevity in your answer.  1.02. What is the ratio of the Enrollment rate (%) in Middle East & North Africa (all income levels) in 1981 to that in 1984?
Offer a terse response. 0.98. What is the ratio of the Enrollment rate (%) of Other small states in 1981 to that in 1984?
Ensure brevity in your answer.  0.97. What is the ratio of the Enrollment rate (%) of Netherlands in 1981 to that in 1984?
Provide a succinct answer. 1.07. What is the ratio of the Enrollment rate (%) in Syrian Arab Republic in 1981 to that in 1984?
Provide a succinct answer. 1.01. What is the ratio of the Enrollment rate (%) in Middle East & North Africa (all income levels) in 1981 to that in 1985?
Ensure brevity in your answer.  0.98. What is the ratio of the Enrollment rate (%) of Other small states in 1981 to that in 1985?
Your response must be concise. 0.95. What is the ratio of the Enrollment rate (%) in Netherlands in 1981 to that in 1985?
Provide a succinct answer. 1.07. What is the ratio of the Enrollment rate (%) of Middle East & North Africa (all income levels) in 1981 to that in 1986?
Make the answer very short. 0.97. What is the ratio of the Enrollment rate (%) in Other small states in 1981 to that in 1986?
Your answer should be compact. 0.96. What is the ratio of the Enrollment rate (%) in Syrian Arab Republic in 1981 to that in 1986?
Your response must be concise. 0.99. What is the ratio of the Enrollment rate (%) of Middle East & North Africa (all income levels) in 1981 to that in 1987?
Ensure brevity in your answer.  0.96. What is the ratio of the Enrollment rate (%) in Other small states in 1981 to that in 1987?
Give a very brief answer. 0.96. What is the ratio of the Enrollment rate (%) in Netherlands in 1981 to that in 1987?
Offer a very short reply. 0.97. What is the ratio of the Enrollment rate (%) of Syrian Arab Republic in 1981 to that in 1987?
Offer a terse response. 0.96. What is the ratio of the Enrollment rate (%) of Middle East & North Africa (all income levels) in 1982 to that in 1983?
Offer a terse response. 1. What is the ratio of the Enrollment rate (%) in Netherlands in 1982 to that in 1983?
Provide a succinct answer. 1.03. What is the ratio of the Enrollment rate (%) of Syrian Arab Republic in 1982 to that in 1983?
Make the answer very short. 1. What is the ratio of the Enrollment rate (%) of Middle East & North Africa (all income levels) in 1982 to that in 1984?
Provide a succinct answer. 0.98. What is the ratio of the Enrollment rate (%) of Netherlands in 1982 to that in 1984?
Make the answer very short. 1.04. What is the ratio of the Enrollment rate (%) in Syrian Arab Republic in 1982 to that in 1984?
Your answer should be very brief. 0.99. What is the ratio of the Enrollment rate (%) of Middle East & North Africa (all income levels) in 1982 to that in 1985?
Ensure brevity in your answer.  0.98. What is the ratio of the Enrollment rate (%) of Other small states in 1982 to that in 1985?
Give a very brief answer. 0.98. What is the ratio of the Enrollment rate (%) of Netherlands in 1982 to that in 1985?
Give a very brief answer. 1.04. What is the ratio of the Enrollment rate (%) in Syrian Arab Republic in 1982 to that in 1985?
Give a very brief answer. 0.99. What is the ratio of the Enrollment rate (%) in Middle East & North Africa (all income levels) in 1982 to that in 1986?
Offer a very short reply. 0.98. What is the ratio of the Enrollment rate (%) of Other small states in 1982 to that in 1986?
Keep it short and to the point. 0.98. What is the ratio of the Enrollment rate (%) in Netherlands in 1982 to that in 1986?
Provide a short and direct response. 0.97. What is the ratio of the Enrollment rate (%) in Syrian Arab Republic in 1982 to that in 1986?
Provide a short and direct response. 0.98. What is the ratio of the Enrollment rate (%) in Other small states in 1982 to that in 1987?
Give a very brief answer. 0.98. What is the ratio of the Enrollment rate (%) of Netherlands in 1982 to that in 1987?
Provide a succinct answer. 0.94. What is the ratio of the Enrollment rate (%) of Syrian Arab Republic in 1982 to that in 1987?
Give a very brief answer. 0.95. What is the ratio of the Enrollment rate (%) in Middle East & North Africa (all income levels) in 1983 to that in 1984?
Give a very brief answer. 0.99. What is the ratio of the Enrollment rate (%) of Other small states in 1983 to that in 1984?
Give a very brief answer. 1. What is the ratio of the Enrollment rate (%) in Netherlands in 1983 to that in 1984?
Your answer should be very brief. 1.01. What is the ratio of the Enrollment rate (%) of Middle East & North Africa (all income levels) in 1983 to that in 1985?
Offer a very short reply. 0.99. What is the ratio of the Enrollment rate (%) of Other small states in 1983 to that in 1985?
Give a very brief answer. 0.98. What is the ratio of the Enrollment rate (%) in Netherlands in 1983 to that in 1985?
Offer a terse response. 1.02. What is the ratio of the Enrollment rate (%) of Syrian Arab Republic in 1983 to that in 1985?
Your response must be concise. 0.98. What is the ratio of the Enrollment rate (%) of Other small states in 1983 to that in 1986?
Keep it short and to the point. 0.99. What is the ratio of the Enrollment rate (%) in Netherlands in 1983 to that in 1986?
Your answer should be very brief. 0.95. What is the ratio of the Enrollment rate (%) in Syrian Arab Republic in 1983 to that in 1986?
Offer a very short reply. 0.97. What is the ratio of the Enrollment rate (%) of Middle East & North Africa (all income levels) in 1983 to that in 1987?
Give a very brief answer. 0.97. What is the ratio of the Enrollment rate (%) of Other small states in 1983 to that in 1987?
Keep it short and to the point. 0.98. What is the ratio of the Enrollment rate (%) in Netherlands in 1983 to that in 1987?
Provide a succinct answer. 0.92. What is the ratio of the Enrollment rate (%) in Syrian Arab Republic in 1983 to that in 1987?
Give a very brief answer. 0.95. What is the ratio of the Enrollment rate (%) of Other small states in 1984 to that in 1985?
Make the answer very short. 0.98. What is the ratio of the Enrollment rate (%) in Netherlands in 1984 to that in 1985?
Your answer should be very brief. 1. What is the ratio of the Enrollment rate (%) of Syrian Arab Republic in 1984 to that in 1985?
Keep it short and to the point. 0.99. What is the ratio of the Enrollment rate (%) of Middle East & North Africa (all income levels) in 1984 to that in 1986?
Your response must be concise. 0.99. What is the ratio of the Enrollment rate (%) in Netherlands in 1984 to that in 1986?
Make the answer very short. 0.93. What is the ratio of the Enrollment rate (%) in Syrian Arab Republic in 1984 to that in 1986?
Ensure brevity in your answer.  0.98. What is the ratio of the Enrollment rate (%) of Middle East & North Africa (all income levels) in 1984 to that in 1987?
Your answer should be compact. 0.98. What is the ratio of the Enrollment rate (%) of Other small states in 1984 to that in 1987?
Provide a succinct answer. 0.99. What is the ratio of the Enrollment rate (%) in Netherlands in 1984 to that in 1987?
Provide a short and direct response. 0.91. What is the ratio of the Enrollment rate (%) of Syrian Arab Republic in 1984 to that in 1987?
Your answer should be compact. 0.96. What is the ratio of the Enrollment rate (%) in Other small states in 1985 to that in 1986?
Offer a terse response. 1.01. What is the ratio of the Enrollment rate (%) in Netherlands in 1985 to that in 1986?
Your answer should be very brief. 0.93. What is the ratio of the Enrollment rate (%) in Syrian Arab Republic in 1985 to that in 1986?
Ensure brevity in your answer.  0.99. What is the ratio of the Enrollment rate (%) in Middle East & North Africa (all income levels) in 1985 to that in 1987?
Make the answer very short. 0.99. What is the ratio of the Enrollment rate (%) of Other small states in 1985 to that in 1987?
Provide a short and direct response. 1. What is the ratio of the Enrollment rate (%) of Netherlands in 1985 to that in 1987?
Keep it short and to the point. 0.91. What is the ratio of the Enrollment rate (%) of Syrian Arab Republic in 1985 to that in 1987?
Give a very brief answer. 0.96. What is the ratio of the Enrollment rate (%) of Other small states in 1986 to that in 1987?
Ensure brevity in your answer.  1. What is the ratio of the Enrollment rate (%) in Netherlands in 1986 to that in 1987?
Ensure brevity in your answer.  0.97. What is the ratio of the Enrollment rate (%) of Syrian Arab Republic in 1986 to that in 1987?
Your response must be concise. 0.97. What is the difference between the highest and the second highest Enrollment rate (%) of Middle East & North Africa (all income levels)?
Your answer should be very brief. 0.74. What is the difference between the highest and the second highest Enrollment rate (%) in Other small states?
Your answer should be compact. 0.25. What is the difference between the highest and the second highest Enrollment rate (%) of Netherlands?
Provide a succinct answer. 2.39. What is the difference between the highest and the second highest Enrollment rate (%) of Syrian Arab Republic?
Your response must be concise. 2.76. What is the difference between the highest and the lowest Enrollment rate (%) of Middle East & North Africa (all income levels)?
Your response must be concise. 3.36. What is the difference between the highest and the lowest Enrollment rate (%) of Other small states?
Offer a very short reply. 3.46. What is the difference between the highest and the lowest Enrollment rate (%) of Netherlands?
Provide a short and direct response. 8.63. What is the difference between the highest and the lowest Enrollment rate (%) of Syrian Arab Republic?
Your answer should be compact. 5.39. 